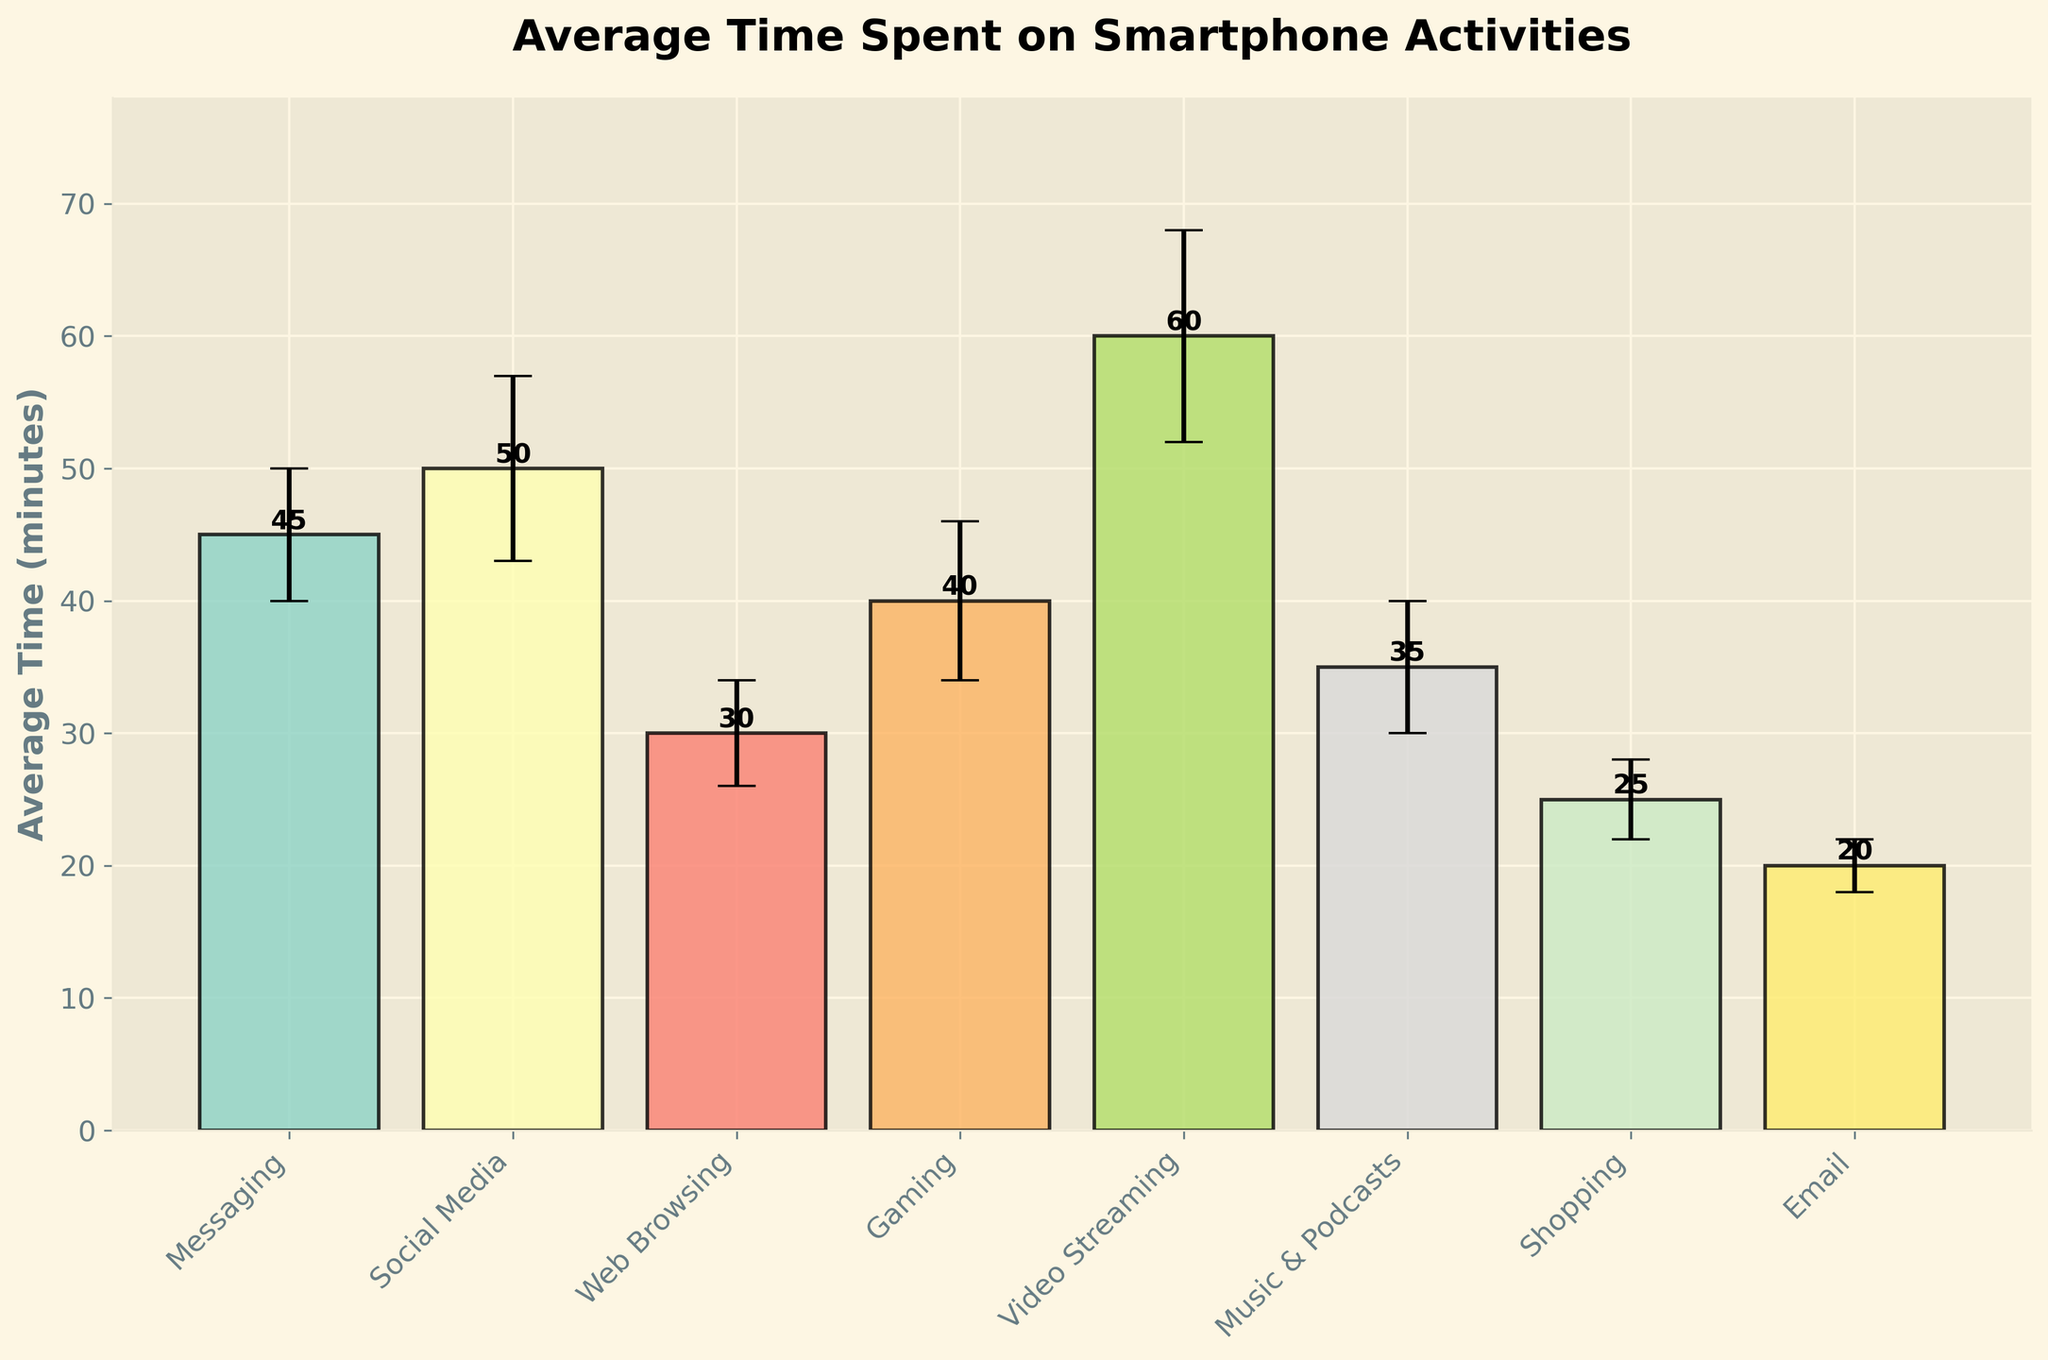What is the title of the figure? The title is usually found at the top of the figure. In this case, it reads "Average Time Spent on Smartphone Activities".
Answer: Average Time Spent on Smartphone Activities What is the average time spent on the activity "Gaming"? Locate the bar labeled "Gaming" and look at its height. The height represents the average time spent.
Answer: 40 minutes Which activity has the highest average time spent? Identify the tallest bar in the figure. The tallest bar represents the activity with the highest average time spent, which is labeled "Video Streaming".
Answer: Video Streaming What are the vertical error margins for the activity "Social Media"? Find the bar labeled "Social Media" and look for the vertical lines extending above and below the top of the bar. These lines represent the error margins. The error margin for "Social Media" is labeled with the data and shows a length of 7 minutes.
Answer: 7 minutes What is the overall range of average times displayed in the figure? To find the range, identify the minimum and maximum average times from the bars. The minimum average time is for "Email" (20 minutes) and the maximum is for "Video Streaming" (60 minutes). Subtract the minimum from the maximum to find the range.
Answer: 40 minutes Which activities have an average time within 5 minutes of 30 minutes? Identify bars with average times between 25 and 35 minutes. The activities with average times within this range are "Web Browsing" (30 minutes) and "Music & Podcasts" (35 minutes).
Answer: Web Browsing, Music & Podcasts How much more time is spent on "Social Media" compared to "Email"? Find the average times for "Social Media" (50 minutes) and "Email" (20 minutes). Subtract the time for "Email" from "Social Media".
Answer: 30 minutes Which activities have error margins higher than 5 minutes? Identify bars with error margins above 5. The activities meeting this criterion are "Social Media" (7 minutes), "Gaming" (6 minutes), and "Video Streaming" (8 minutes).
Answer: Social Media, Gaming, Video Streaming Is the error margin for "Messaging" greater than the average time for "Email"? Compare the error margin for "Messaging" (5 minutes) with the average time for "Email" (20 minutes). The error margin for "Messaging" is less than the average time for "Email".
Answer: No What is the total average time spent on "Messaging" and "Shopping"? Find the average times for "Messaging" (45 minutes) and "Shopping" (25 minutes). Add these times together.
Answer: 70 minutes 